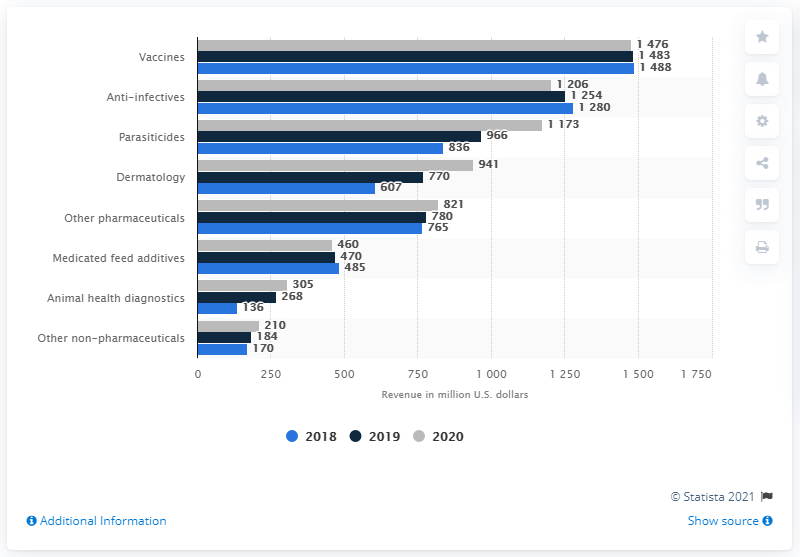Identify some key points in this picture. In 2018, vaccines generated approximately $148.8 billion in revenue in the United States. The total value of all bars in the Dermatology category is 2,318. The chart shows the categories and their corresponding values. The category that recorded the highest value is vaccines. 